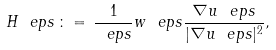Convert formula to latex. <formula><loc_0><loc_0><loc_500><loc_500>H _ { \ } e p s \, \colon = \, \frac { 1 } { \ e p s } w _ { \ } e p s \frac { \nabla u _ { \ } e p s } { | \nabla u _ { \ } e p s | ^ { 2 } } ,</formula> 